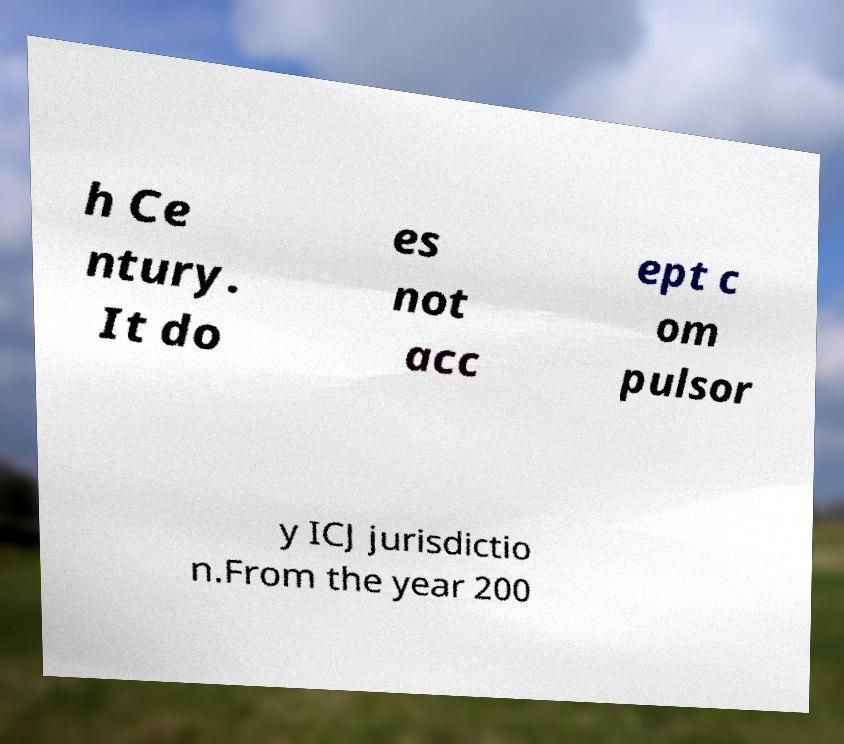There's text embedded in this image that I need extracted. Can you transcribe it verbatim? h Ce ntury. It do es not acc ept c om pulsor y ICJ jurisdictio n.From the year 200 